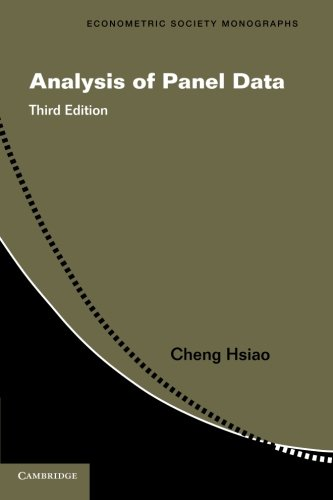Who is the author of this book?
Answer the question using a single word or phrase. Cheng Hsiao What is the title of this book? Analysis of Panel Data (Econometric Society Monographs) What type of book is this? Business & Money Is this book related to Business & Money? Yes Is this book related to Engineering & Transportation? No 